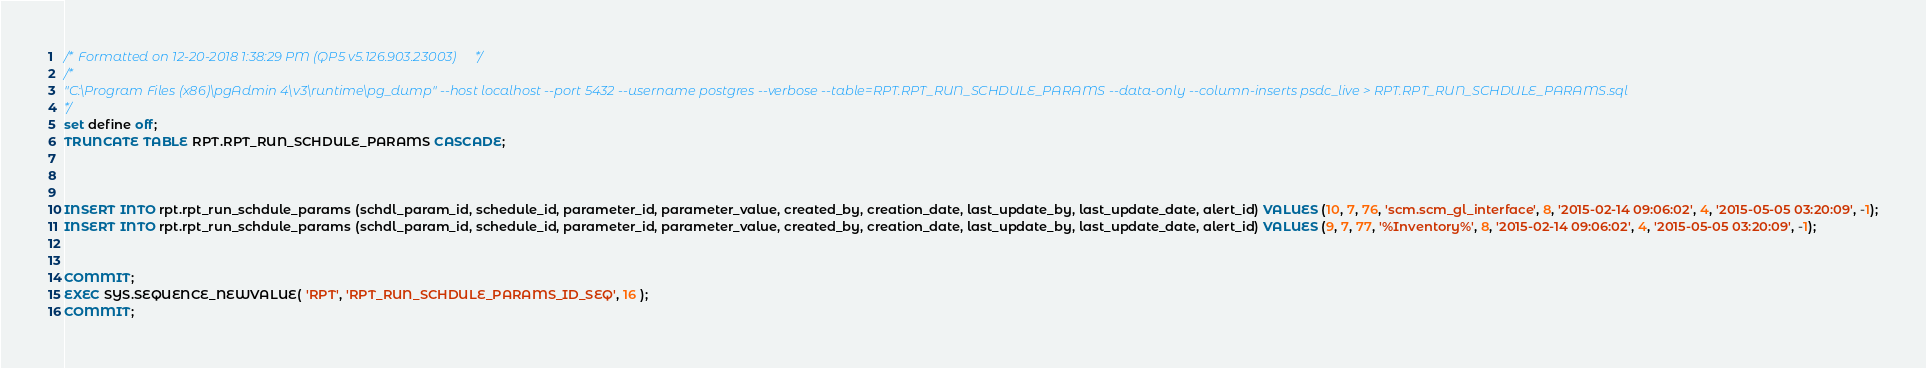<code> <loc_0><loc_0><loc_500><loc_500><_SQL_>/* Formatted on 12-20-2018 1:38:29 PM (QP5 v5.126.903.23003) */
/*
"C:\Program Files (x86)\pgAdmin 4\v3\runtime\pg_dump" --host localhost --port 5432 --username postgres --verbose --table=RPT.RPT_RUN_SCHDULE_PARAMS --data-only --column-inserts psdc_live > RPT.RPT_RUN_SCHDULE_PARAMS.sql
*/
set define off;
TRUNCATE TABLE RPT.RPT_RUN_SCHDULE_PARAMS CASCADE;



INSERT INTO rpt.rpt_run_schdule_params (schdl_param_id, schedule_id, parameter_id, parameter_value, created_by, creation_date, last_update_by, last_update_date, alert_id) VALUES (10, 7, 76, 'scm.scm_gl_interface', 8, '2015-02-14 09:06:02', 4, '2015-05-05 03:20:09', -1);
INSERT INTO rpt.rpt_run_schdule_params (schdl_param_id, schedule_id, parameter_id, parameter_value, created_by, creation_date, last_update_by, last_update_date, alert_id) VALUES (9, 7, 77, '%Inventory%', 8, '2015-02-14 09:06:02', 4, '2015-05-05 03:20:09', -1);


COMMIT;
EXEC SYS.SEQUENCE_NEWVALUE( 'RPT', 'RPT_RUN_SCHDULE_PARAMS_ID_SEQ', 16 );
COMMIT;
</code> 